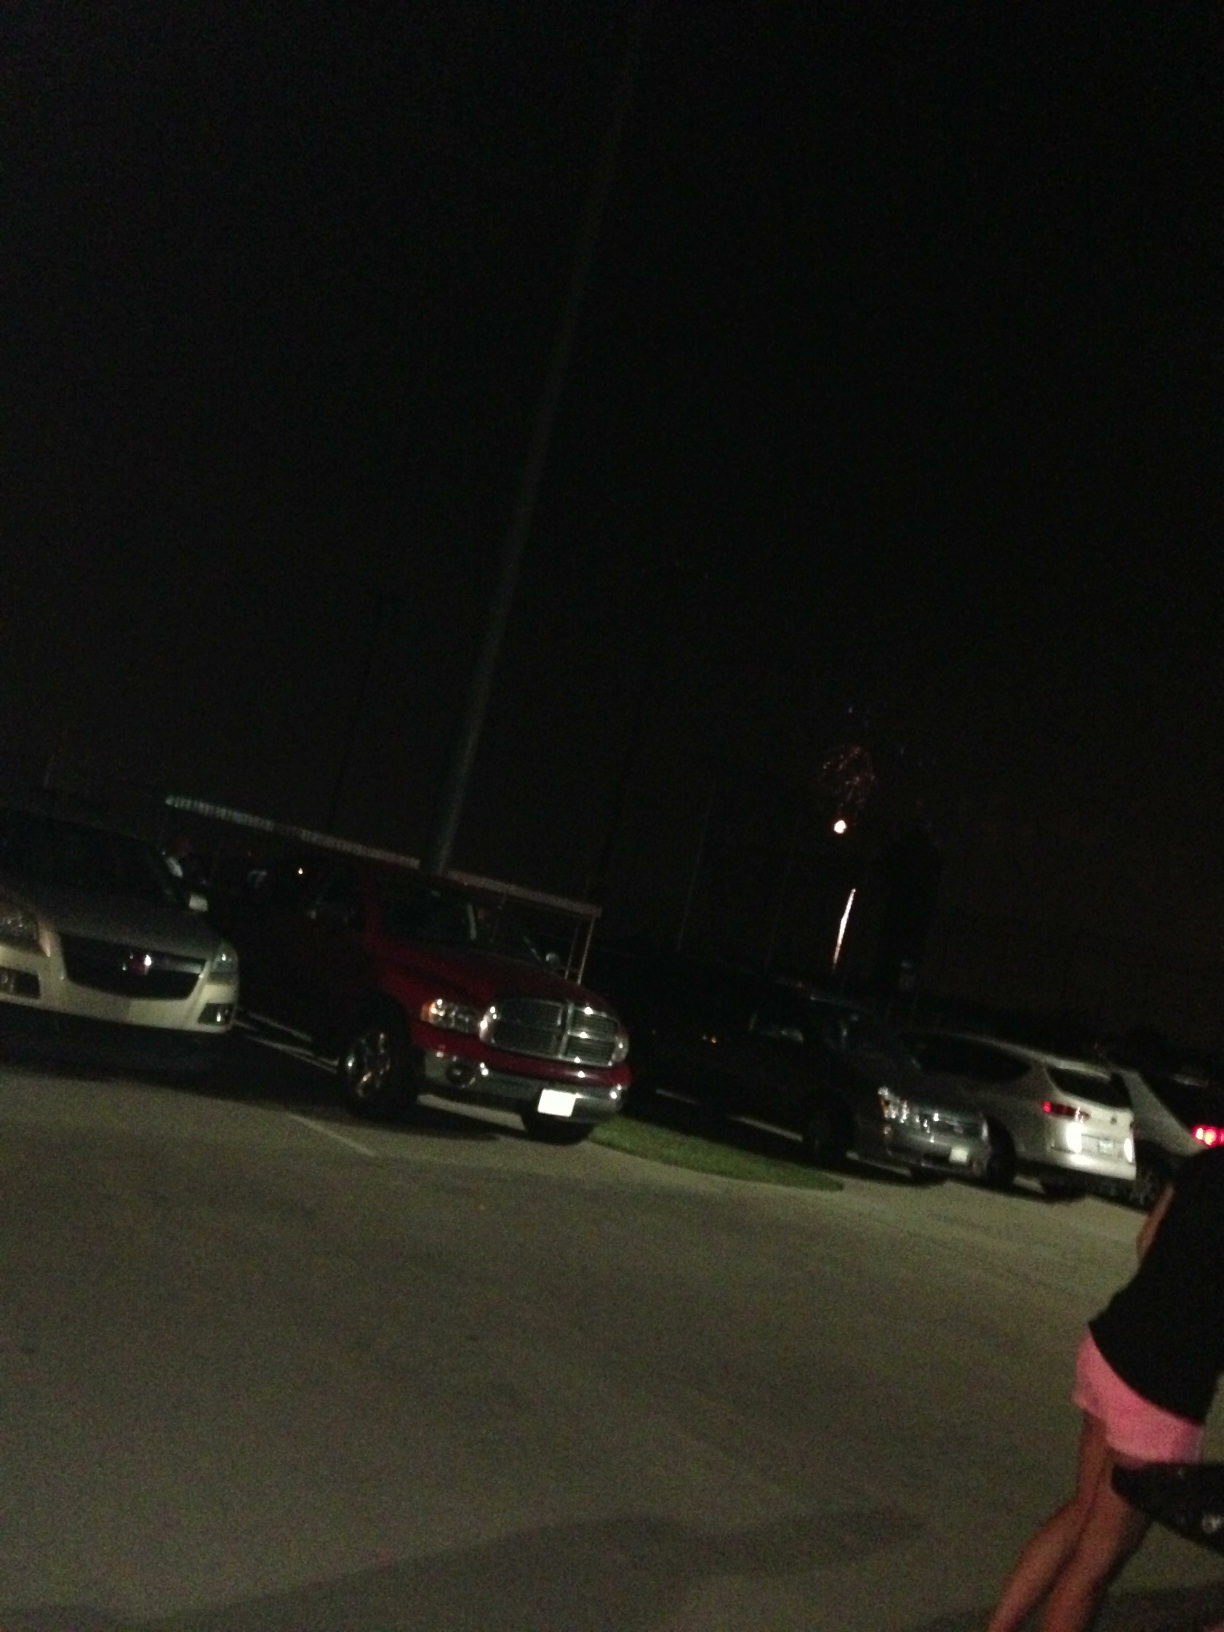Can you describe any activities that might be happening around this area? It looks like people might have gathered in this parking lot to watch fireworks, possibly for a national holiday or local festival. Is it safe in this location during the event? It's often safe during such events, especially in public or organized areas, but it's always good to stay aware of your surroundings and follow any official guidance or event rules. 